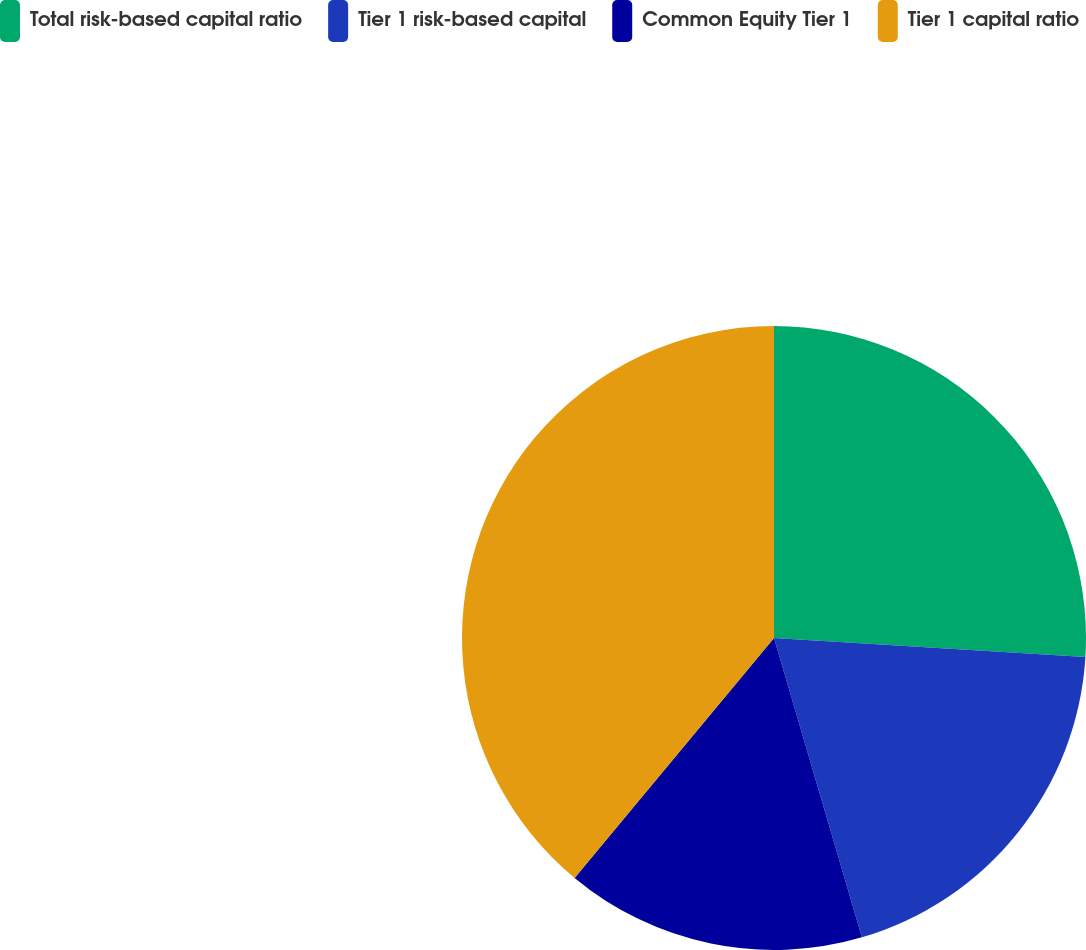Convert chart to OTSL. <chart><loc_0><loc_0><loc_500><loc_500><pie_chart><fcel>Total risk-based capital ratio<fcel>Tier 1 risk-based capital<fcel>Common Equity Tier 1<fcel>Tier 1 capital ratio<nl><fcel>25.97%<fcel>19.48%<fcel>15.58%<fcel>38.96%<nl></chart> 